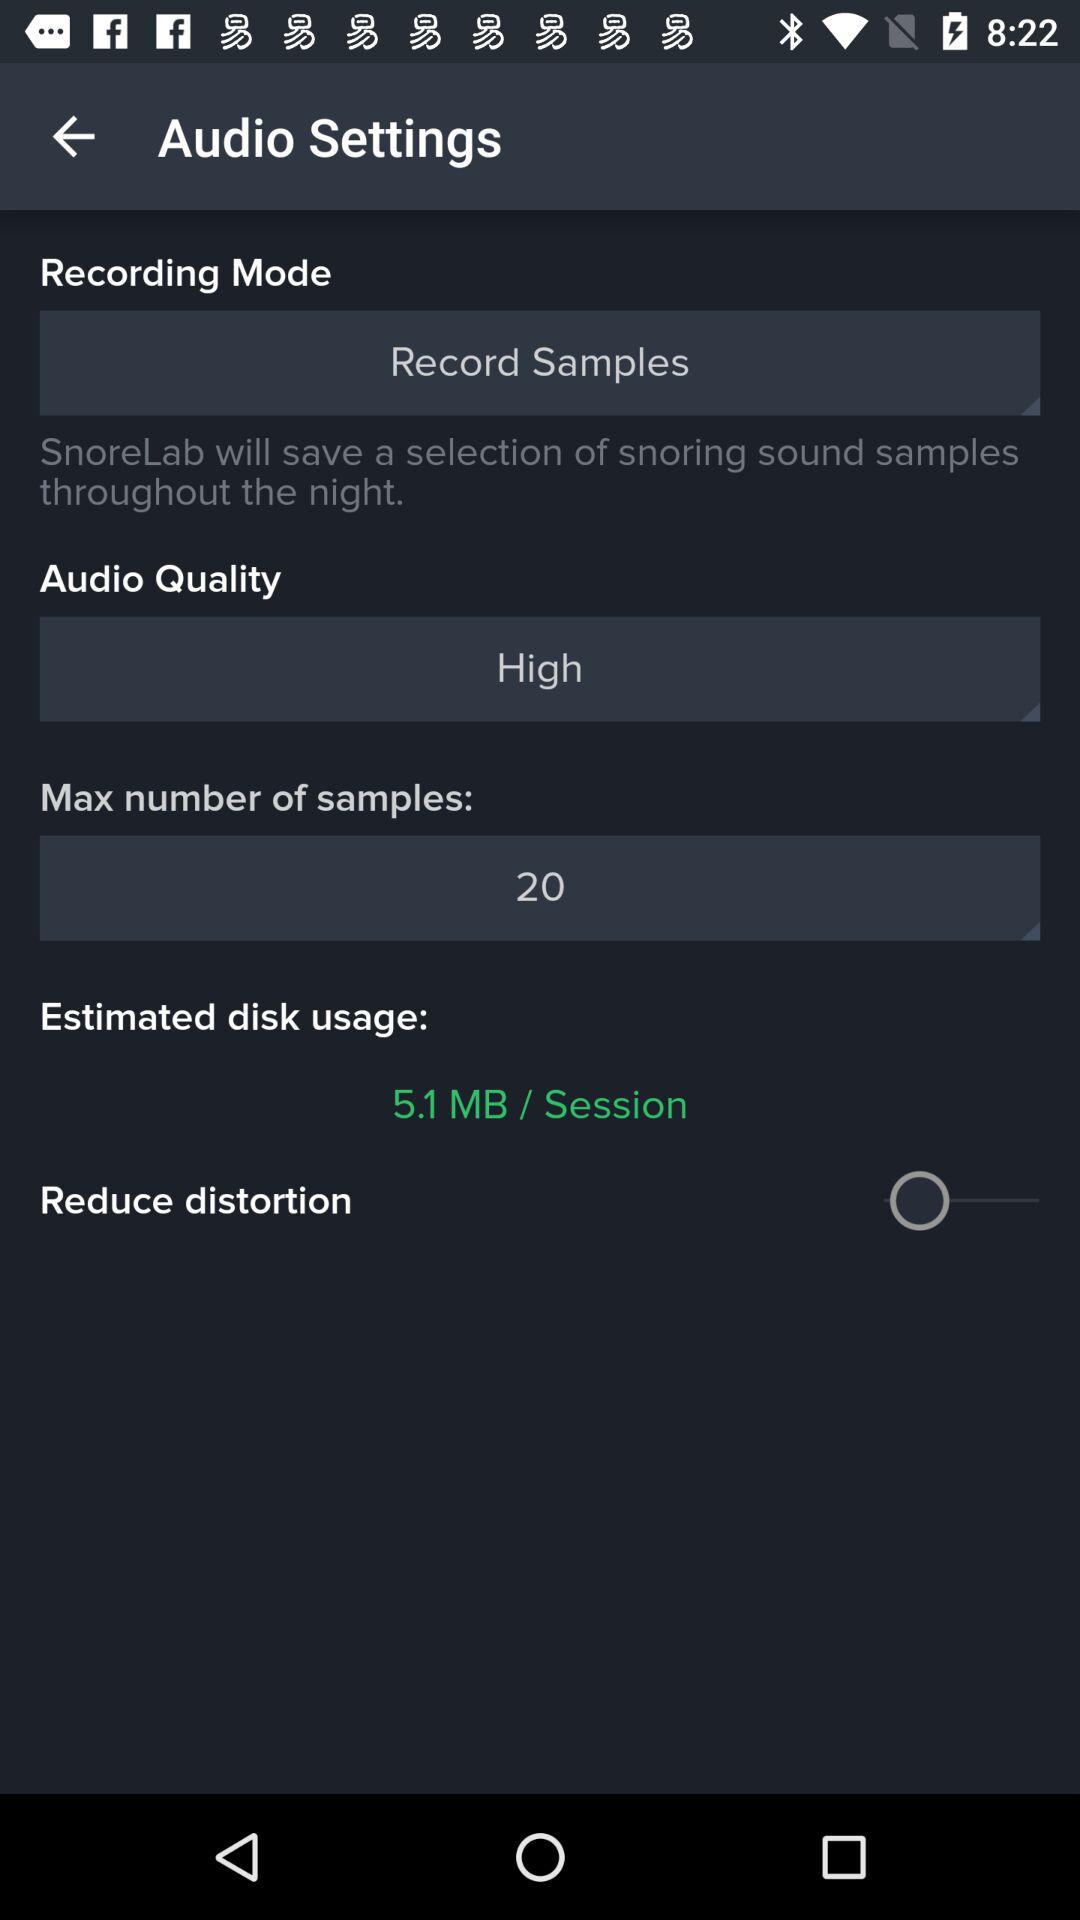How many MB of disk space does SnoreLab estimate will be used per session?
Answer the question using a single word or phrase. 5.1 